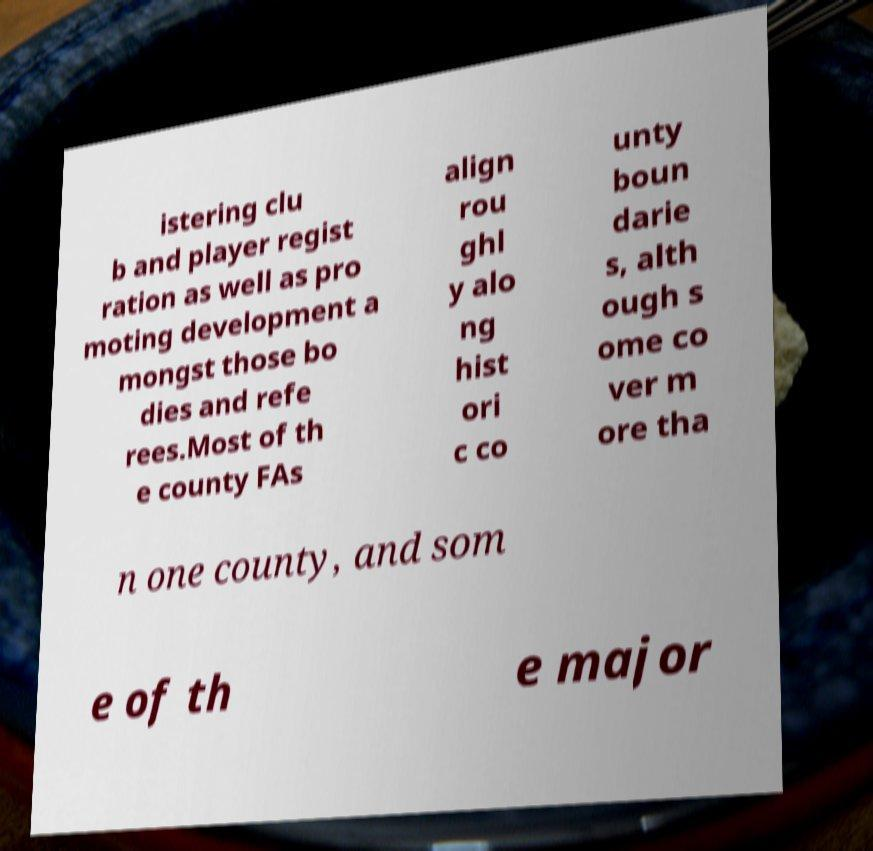There's text embedded in this image that I need extracted. Can you transcribe it verbatim? istering clu b and player regist ration as well as pro moting development a mongst those bo dies and refe rees.Most of th e county FAs align rou ghl y alo ng hist ori c co unty boun darie s, alth ough s ome co ver m ore tha n one county, and som e of th e major 